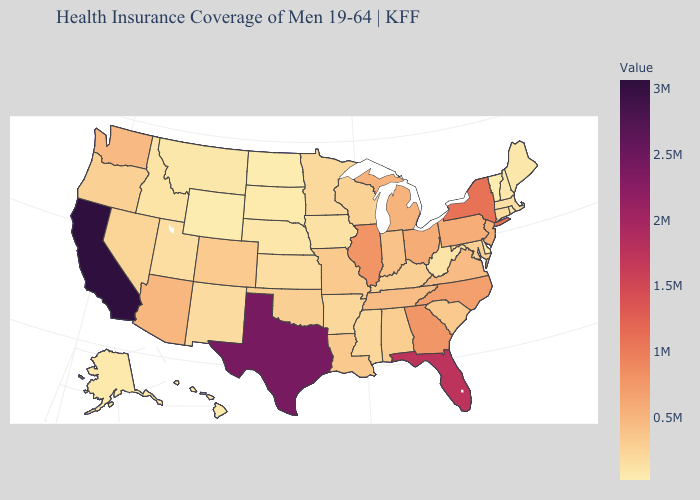Does Wisconsin have a lower value than Georgia?
Write a very short answer. Yes. Among the states that border Ohio , does Indiana have the highest value?
Write a very short answer. No. Does Arizona have a higher value than New Mexico?
Short answer required. Yes. Does New York have the highest value in the Northeast?
Write a very short answer. Yes. 